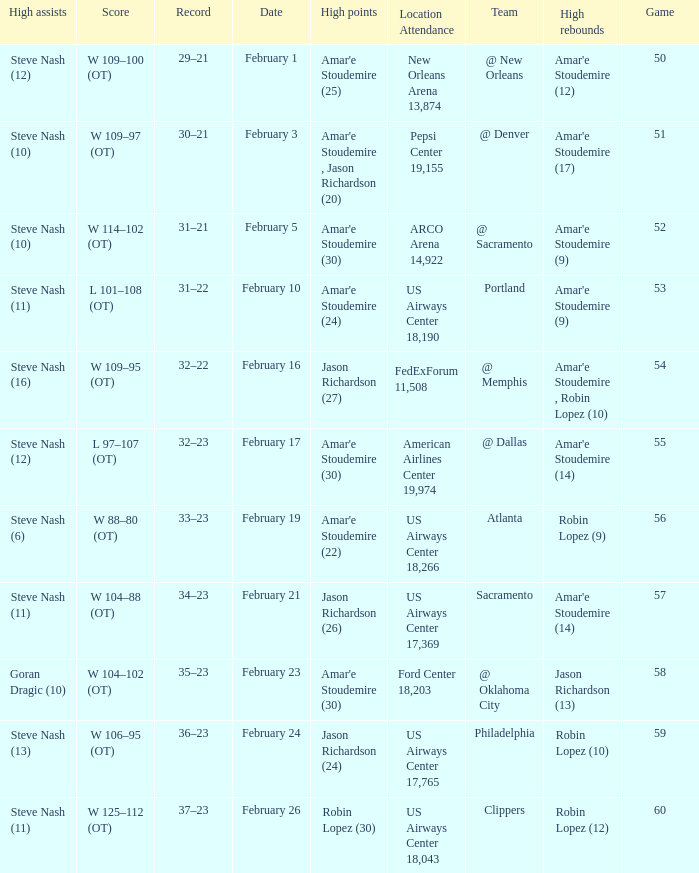Name the date for score w 109–95 (ot) February 16. 